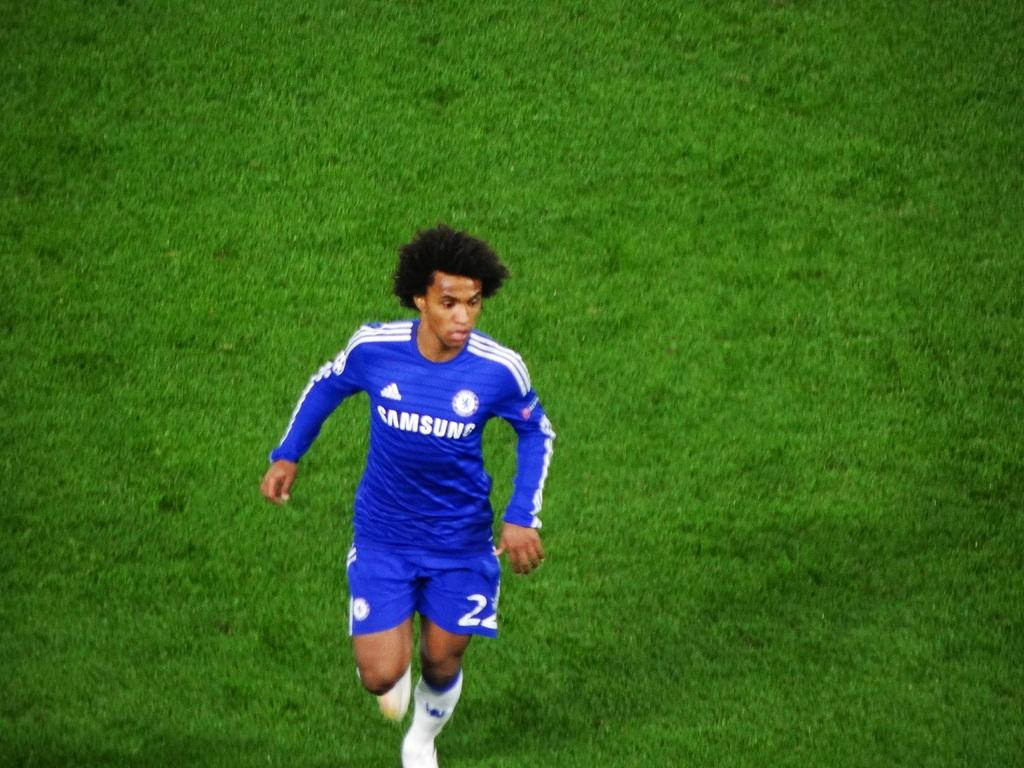<image>
Write a terse but informative summary of the picture. Man wearing a soccer jersey with the word Samsung on it. 